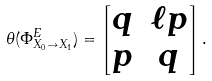<formula> <loc_0><loc_0><loc_500><loc_500>\theta ( \Phi _ { X _ { 0 } \to X _ { 1 } } ^ { E } ) = \begin{bmatrix} q & \ell p \\ p & q \end{bmatrix} .</formula> 